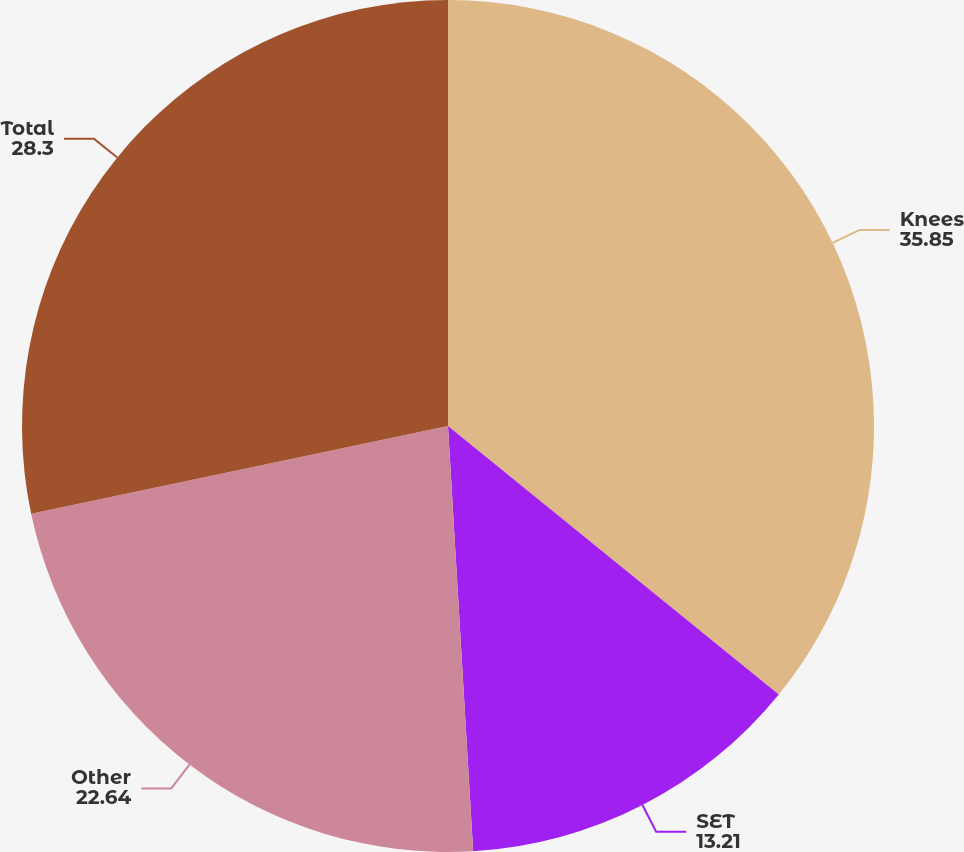Convert chart to OTSL. <chart><loc_0><loc_0><loc_500><loc_500><pie_chart><fcel>Knees<fcel>SET<fcel>Other<fcel>Total<nl><fcel>35.85%<fcel>13.21%<fcel>22.64%<fcel>28.3%<nl></chart> 